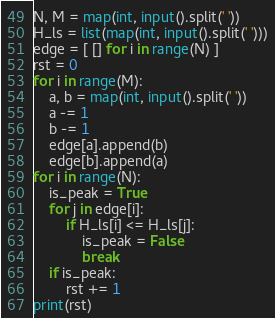<code> <loc_0><loc_0><loc_500><loc_500><_Python_>N, M = map(int, input().split(' '))
H_ls = list(map(int, input().split(' ')))
edge = [ [] for i in range(N) ]
rst = 0
for i in range(M):
    a, b = map(int, input().split(' '))
    a -= 1
    b -= 1
    edge[a].append(b)
    edge[b].append(a)
for i in range(N):
    is_peak = True
    for j in edge[i]:
        if H_ls[i] <= H_ls[j]:
            is_peak = False
            break
    if is_peak:
        rst += 1
print(rst)</code> 